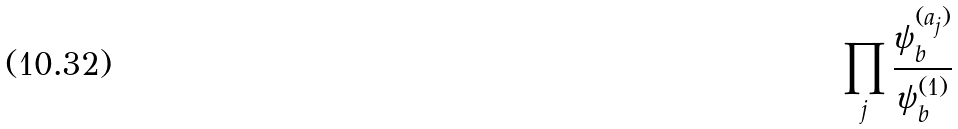Convert formula to latex. <formula><loc_0><loc_0><loc_500><loc_500>\prod _ { j } \frac { \psi _ { b } ^ { ( a _ { j } ) } } { \psi _ { b } ^ { ( 1 ) } }</formula> 